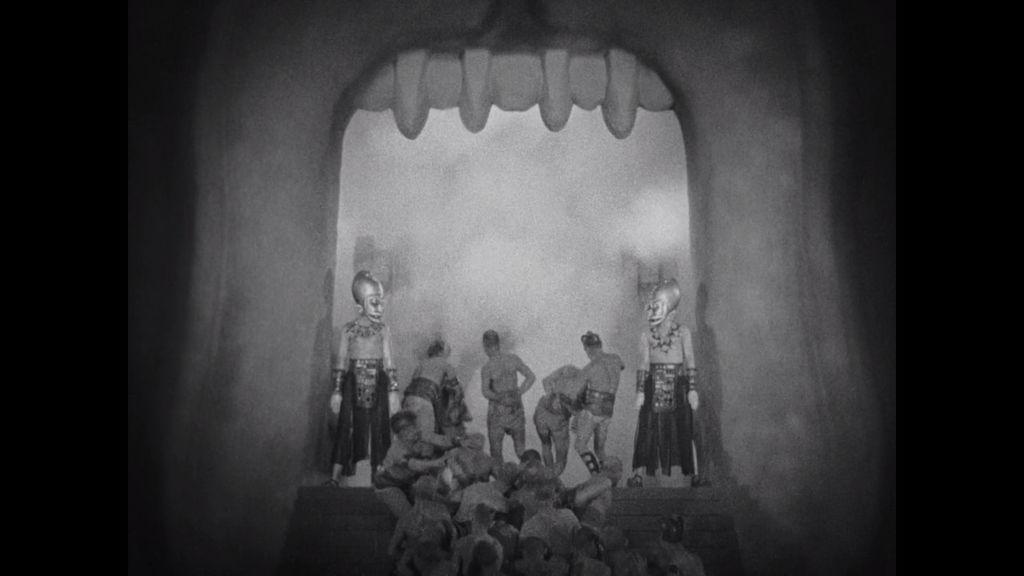Can you describe this image briefly? It is a black and white image. In this image there are few people performing in a play. 